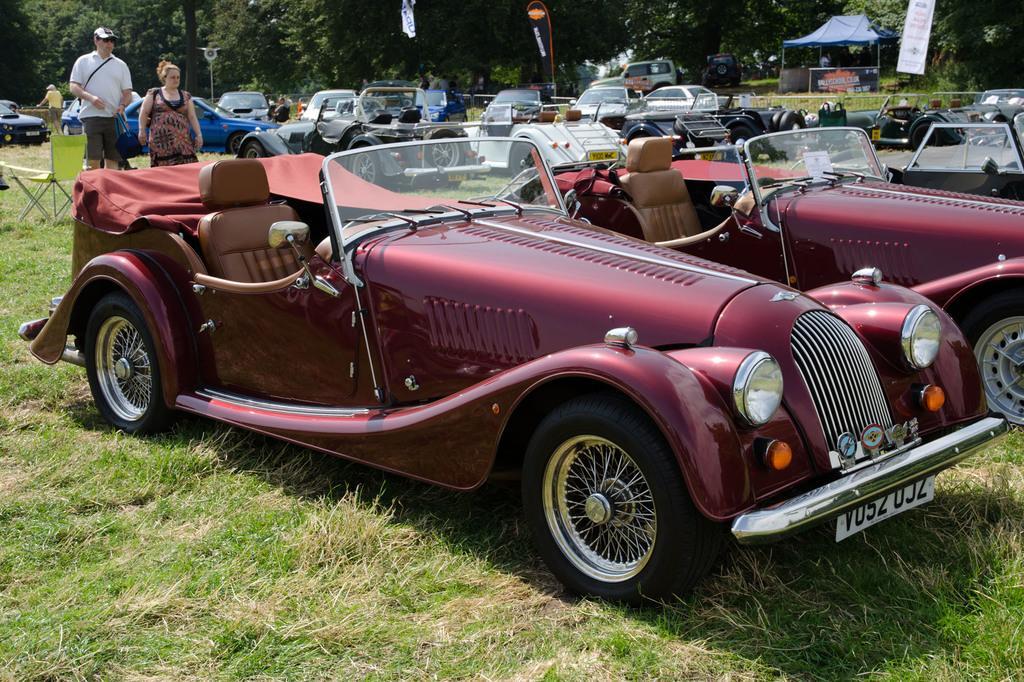How would you summarize this image in a sentence or two? In this image we can see group of vehicles parked on the ground. To the left side of the image we can see two persons standing on the ground. One person wearing a white shirt and cap is holding a bag in his hand and a chair is placed on the ground. In the background, we can see a tent, a group of trees, banners. 